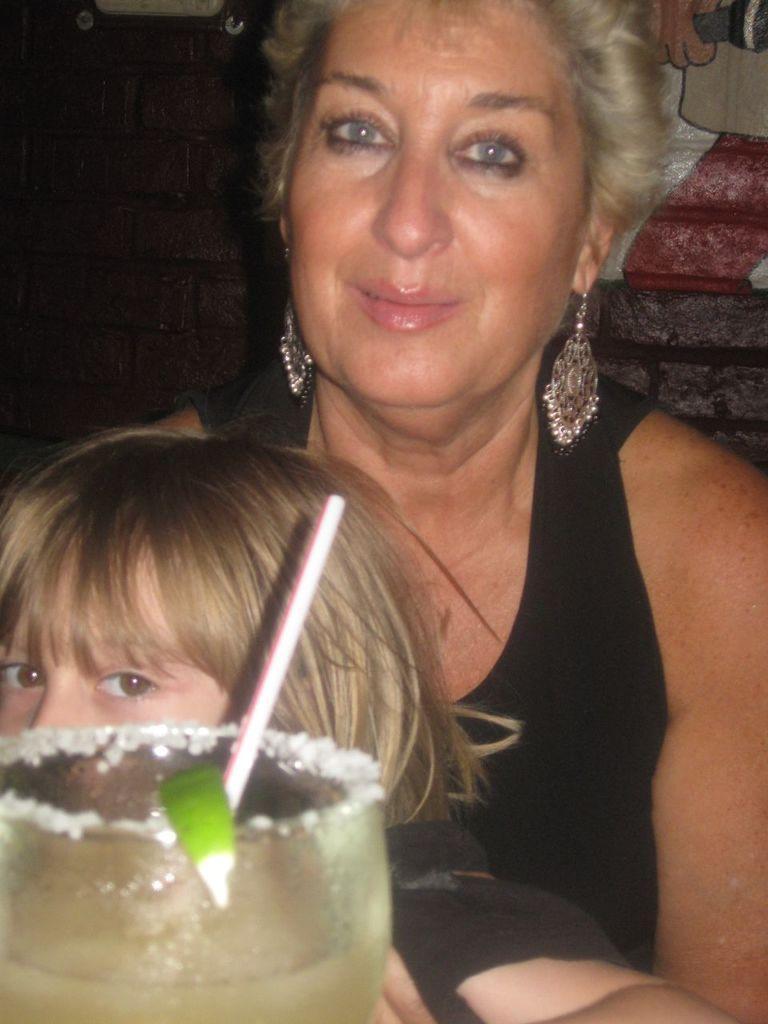Describe this image in one or two sentences. In this picture we can see a woman holding a kid in the front, at the left bottom there is a glass of drink and a straw, in the background we can see a wall, there is a frame at the top of the picture, on the right side we can see a painting. 